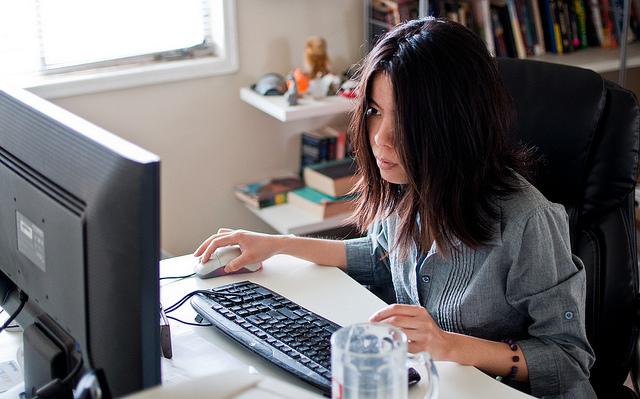What is her right hand on?
Give a very brief answer. Mouse. What kind of computer?
Give a very brief answer. Desktop. How many books are there?
Answer briefly. 20. 